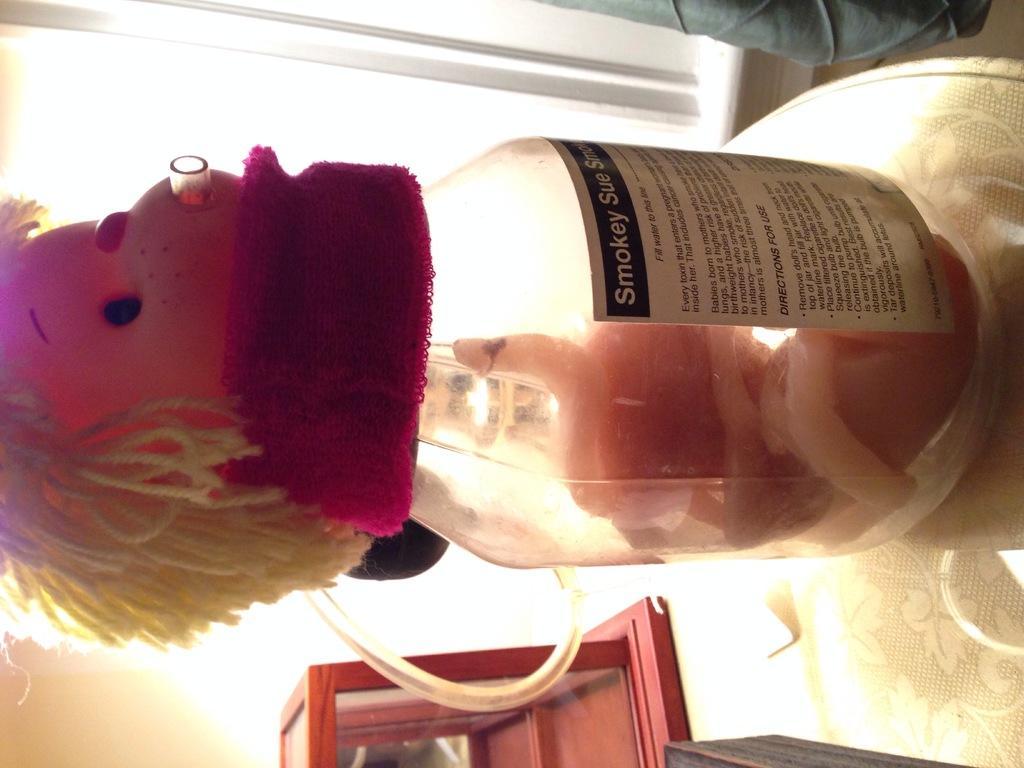Can you describe this image briefly? In this image in the middle there, is a bottle on that there is a doll, inside the bottle there is a snake. On the left there is a door. At the top there is a person. On the left there is a table. 